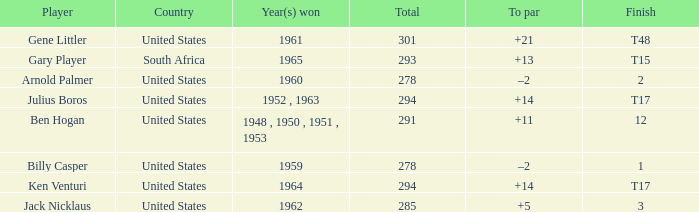What is Year(s) Won, when Total is less than 285? 1959, 1960. 